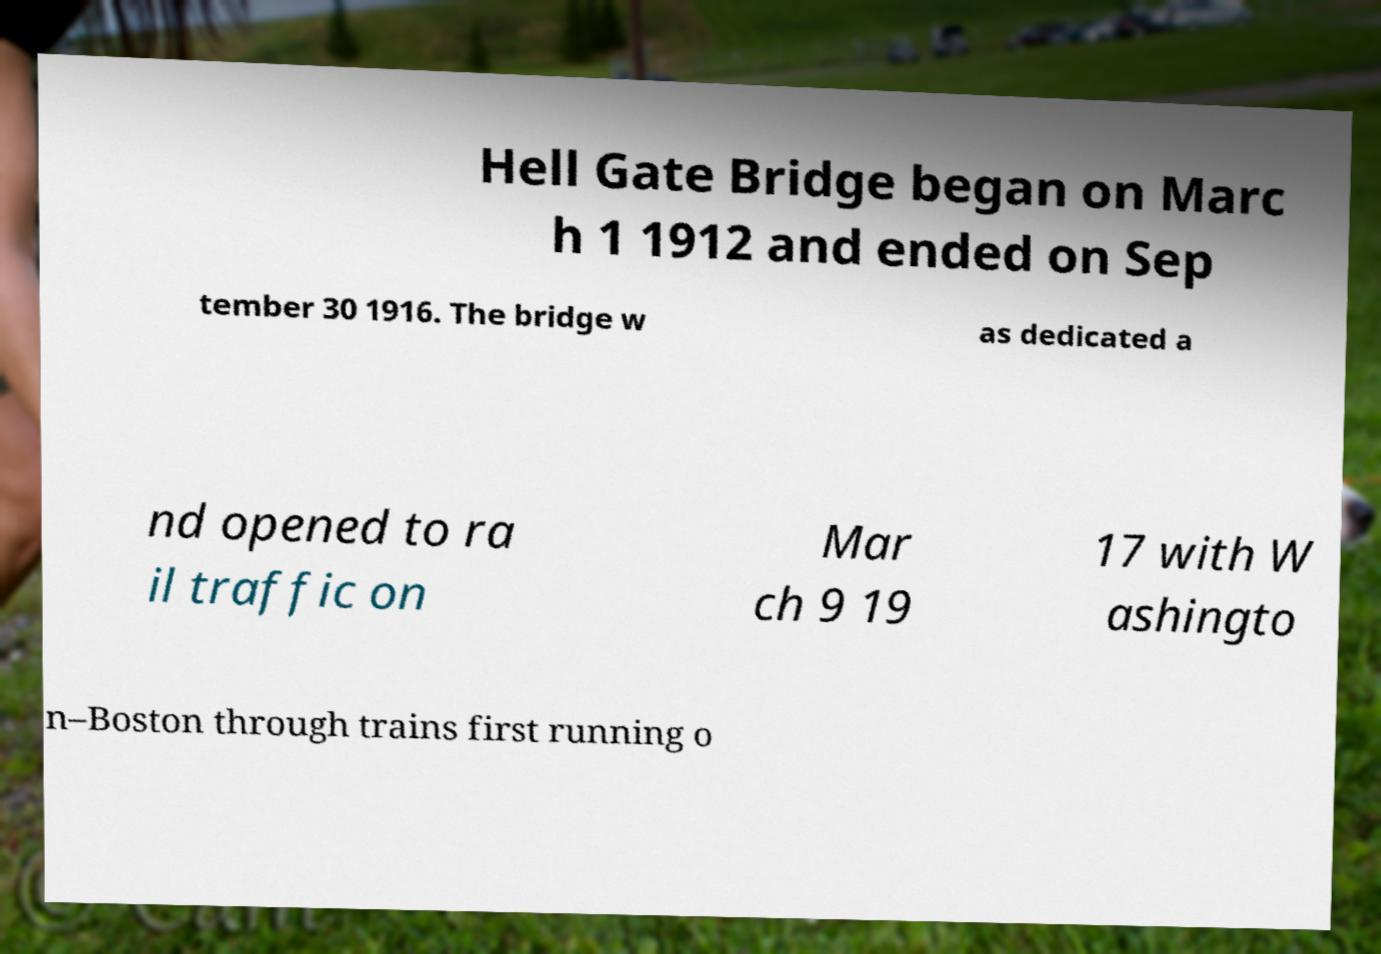Can you read and provide the text displayed in the image?This photo seems to have some interesting text. Can you extract and type it out for me? Hell Gate Bridge began on Marc h 1 1912 and ended on Sep tember 30 1916. The bridge w as dedicated a nd opened to ra il traffic on Mar ch 9 19 17 with W ashingto n–Boston through trains first running o 